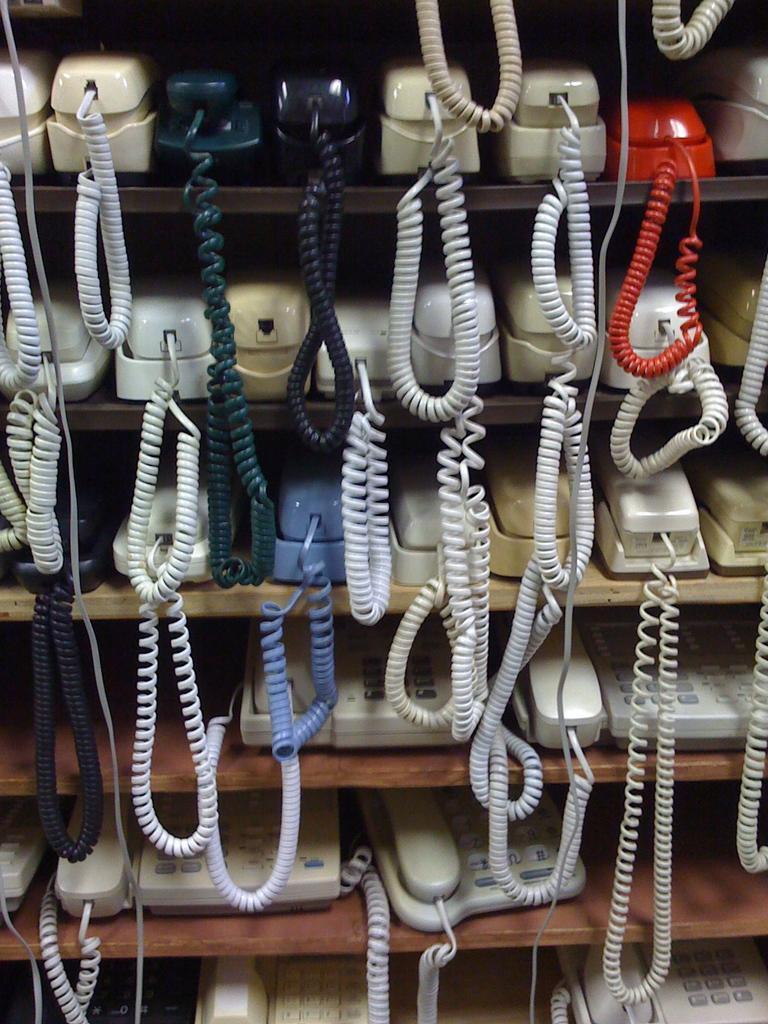Describe this image in one or two sentences. In this image I can see many cellphones inside the cupboard. These telephones are in cream, black, green, white, red and blue color. 